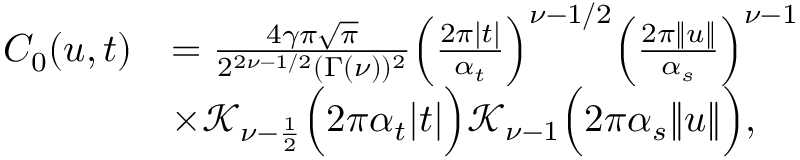Convert formula to latex. <formula><loc_0><loc_0><loc_500><loc_500>\begin{array} { r l } { C _ { 0 } ( u , t ) } & { = \frac { 4 \gamma \pi \sqrt { \pi } } { 2 ^ { 2 \nu - 1 / 2 } ( \Gamma ( \nu ) ) ^ { 2 } } \left ( \frac { 2 \pi | t | } { \alpha _ { t } } \right ) ^ { \nu - 1 / 2 } \left ( \frac { 2 \pi \| u \| } { \alpha _ { s } } \right ) ^ { \nu - 1 } } \\ & { \times \mathcal { K } _ { \nu - \frac { 1 } { 2 } } \left ( 2 \pi \alpha _ { t } | t | \right ) \mathcal { K } _ { \nu - 1 } \left ( 2 \pi \alpha _ { s } \| u \| \right ) , } \end{array}</formula> 